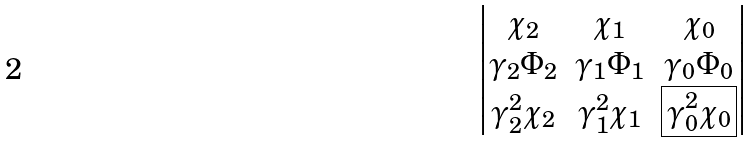<formula> <loc_0><loc_0><loc_500><loc_500>\begin{vmatrix} \chi _ { 2 } & \chi _ { 1 } & \chi _ { 0 } \\ \gamma _ { 2 } \Phi _ { 2 } & \gamma _ { 1 } \Phi _ { 1 } & \gamma _ { 0 } \Phi _ { 0 } \\ \gamma ^ { 2 } _ { 2 } \chi _ { 2 } & \gamma ^ { 2 } _ { 1 } \chi _ { 1 } & { \boxed { \gamma ^ { 2 } _ { 0 } \chi _ { 0 } } } \end{vmatrix}</formula> 